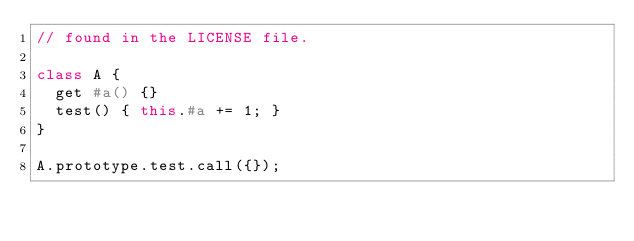Convert code to text. <code><loc_0><loc_0><loc_500><loc_500><_JavaScript_>// found in the LICENSE file.

class A {
  get #a() {}
  test() { this.#a += 1; }
}

A.prototype.test.call({});
</code> 